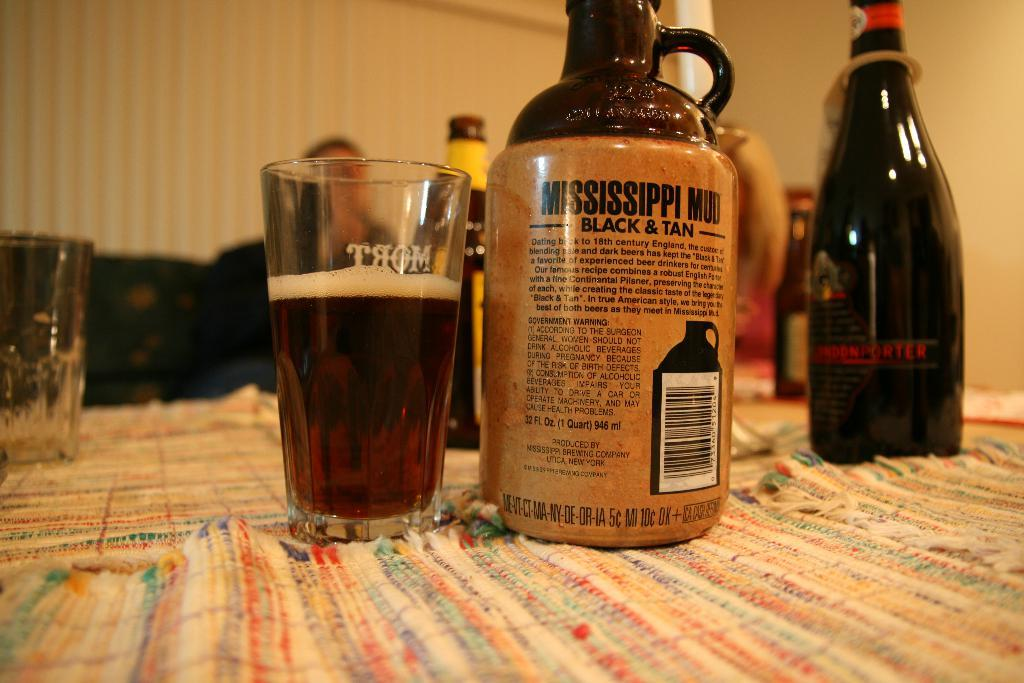<image>
Provide a brief description of the given image. A bottle of Mississippi mud sits on a table. 